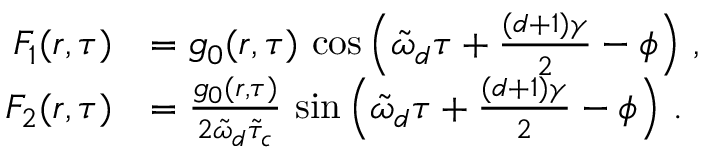<formula> <loc_0><loc_0><loc_500><loc_500>\begin{array} { r l } { F _ { 1 } ( r , \tau ) } & { = g _ { 0 } ( r , \tau ) \, \cos \left ( \tilde { \omega } _ { d } \tau + \frac { ( d + 1 ) \gamma } { 2 } - \phi \right ) \, , } \\ { F _ { 2 } ( r , \tau ) } & { = \frac { g _ { 0 } ( r , \tau ) } { 2 \tilde { \omega } _ { d } \tilde { \tau } _ { c } } \, \sin \left ( \tilde { \omega } _ { d } \tau + \frac { ( d + 1 ) \gamma } { 2 } - \phi \right ) \, . } \end{array}</formula> 